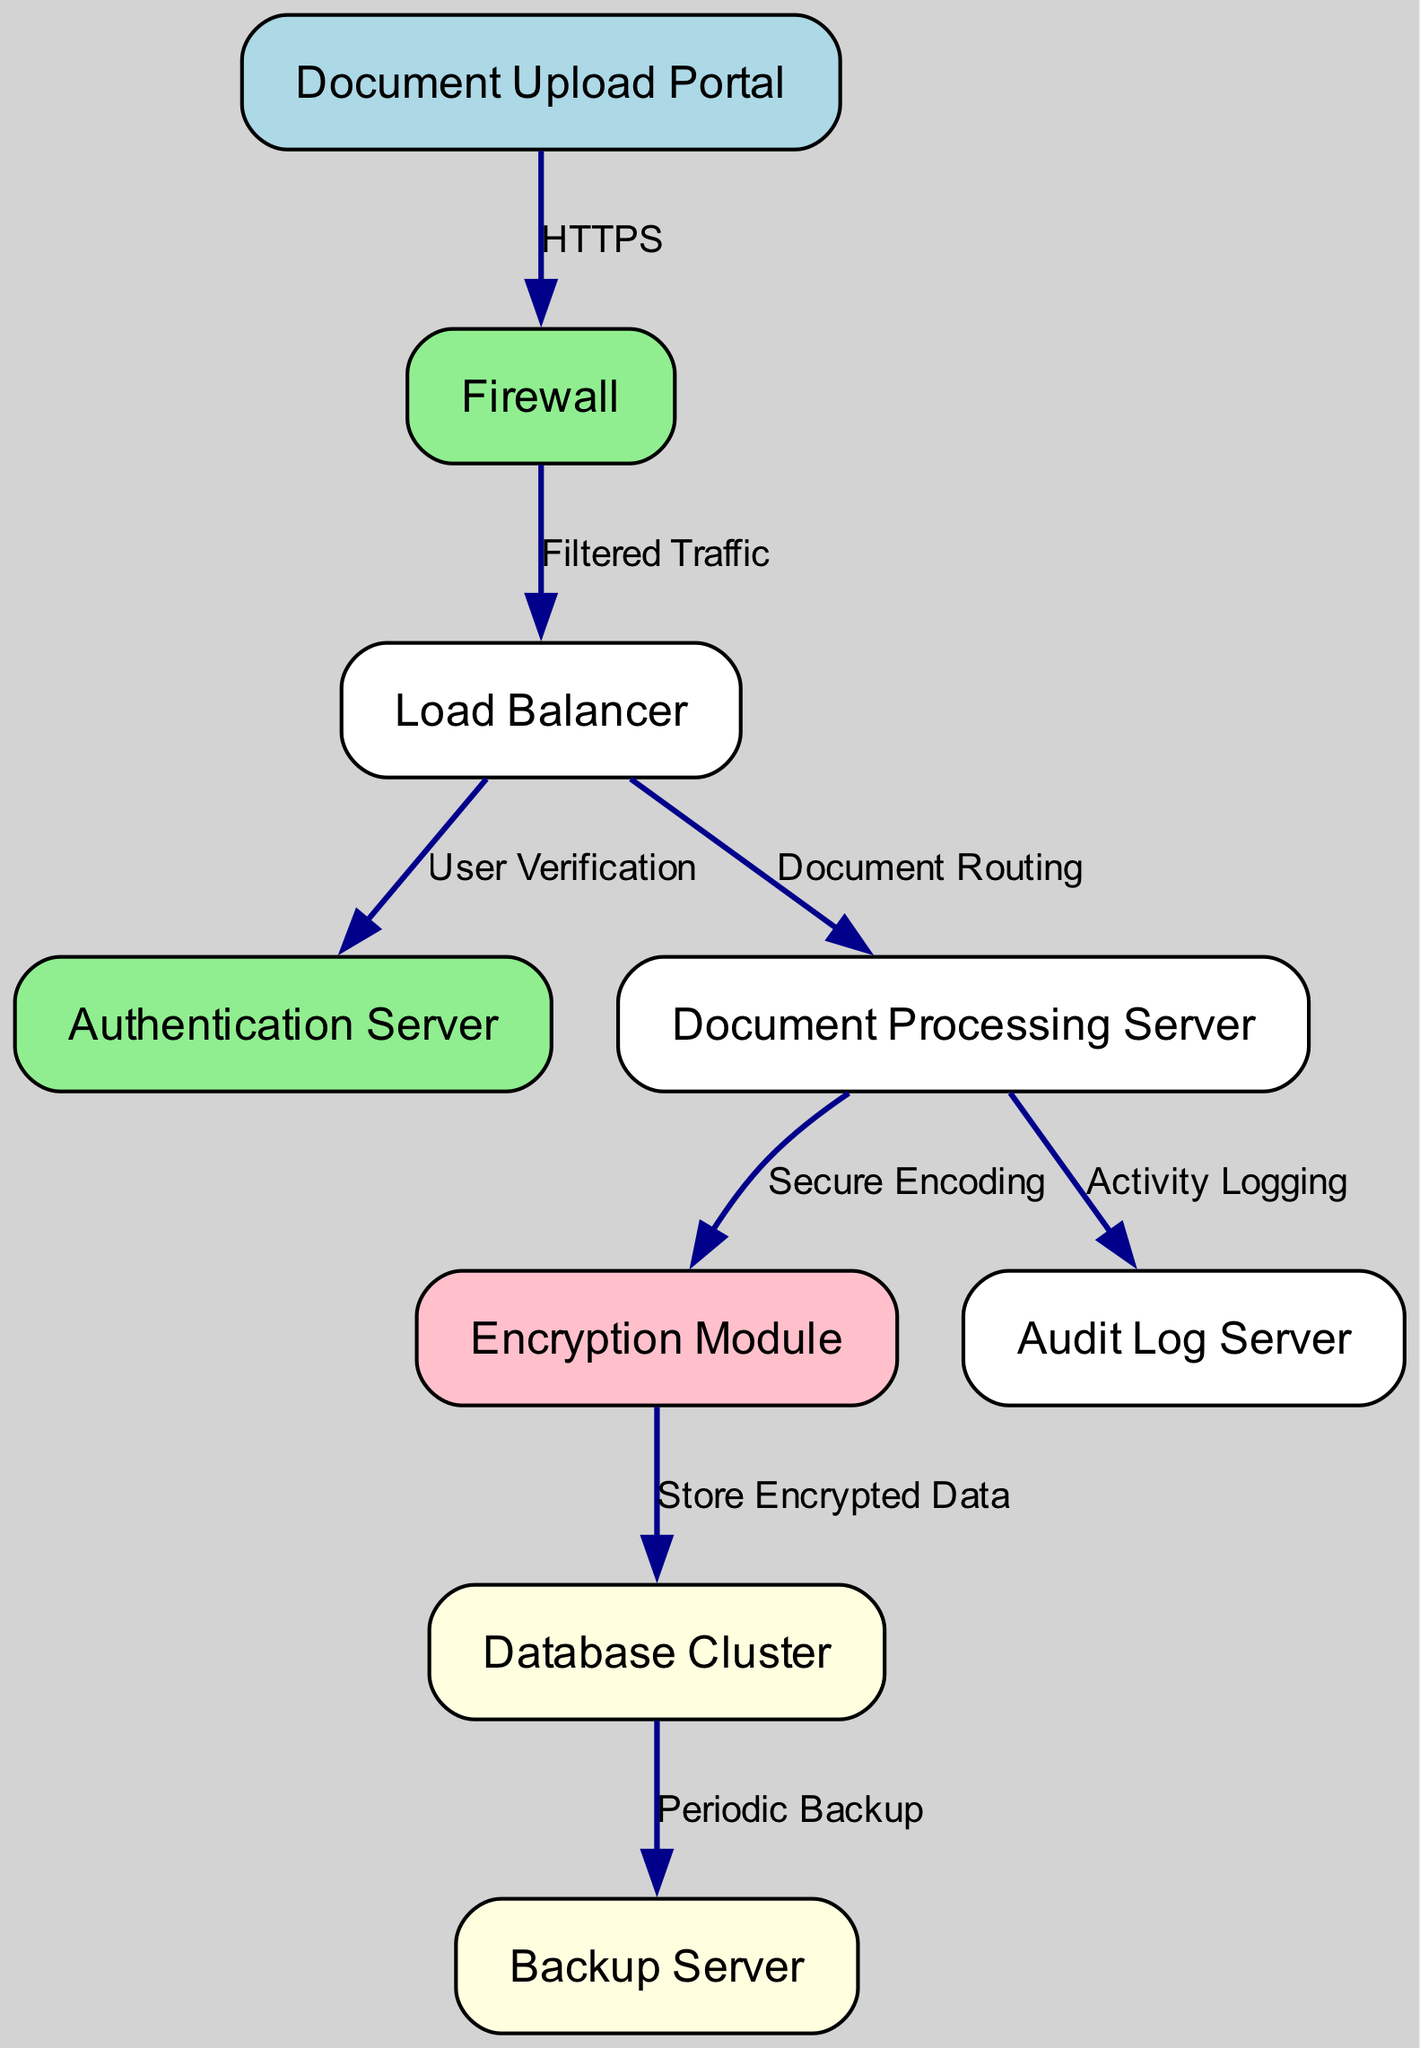What is the starting point for document submission? The starting point in the diagram where users upload documents is indicated by the node labeled "Document Upload Portal".
Answer: Document Upload Portal How many servers are involved in document processing? In the diagram, there are three server nodes involved in document processing: "Document Processing Server", "Database Cluster", and "Backup Server".
Answer: Three What type of data transmission occurs between the Document Upload Portal and the Firewall? The edge between the "Document Upload Portal" and "Firewall" is labeled "HTTPS", indicating this secure data transmission type.
Answer: HTTPS Which component is responsible for storing encrypted data? The "Database Cluster" node is connected to the "Encryption Module" and labeled with the function to store encrypted data.
Answer: Database Cluster What processes data after a user has been verified? The "Document Processing Server" is responsible for processing data immediately after user verification by the "Authentication Server".
Answer: Document Processing Server How does the system ensure the security of documents during upload? The system employs a "Firewall" to filter incoming traffic from the "Document Upload Portal", ensuring only safe uploads are processed.
Answer: Firewall Which module is connected to the Document Processing Server for secure data handling? The "Encryption Module" is directly connected to the "Document Processing Server" and is involved in secure data handling by encoding documents.
Answer: Encryption Module What is the primary function of the Audit Log Server in the diagram? The "Audit Log Server" is responsible for logging activities, as indicated by its direct connection from the "Document Processing Server".
Answer: Activity Logging How are backups managed within the system? The "Database Cluster" node connects to a "Backup Server", which indicates that it manages data backups periodically as represented in the diagram.
Answer: Backup Server 